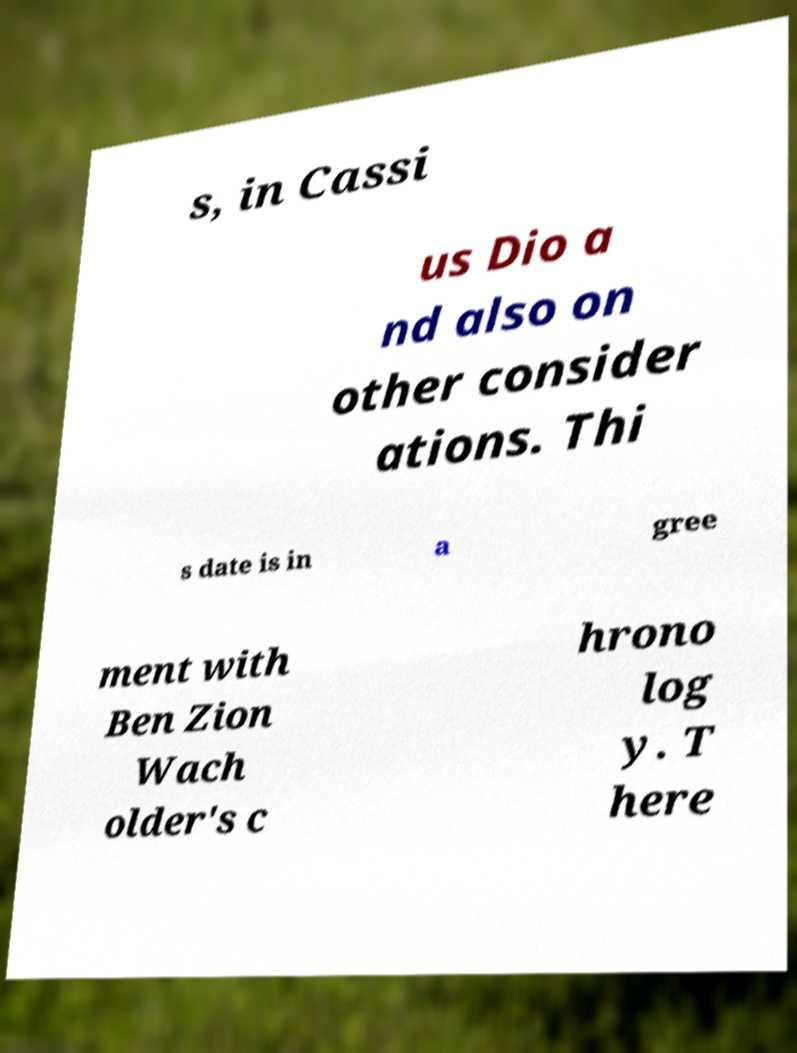There's text embedded in this image that I need extracted. Can you transcribe it verbatim? s, in Cassi us Dio a nd also on other consider ations. Thi s date is in a gree ment with Ben Zion Wach older's c hrono log y. T here 